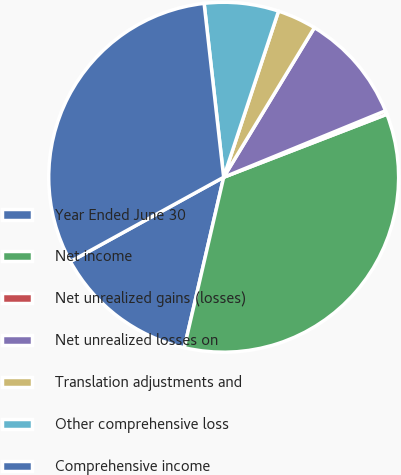<chart> <loc_0><loc_0><loc_500><loc_500><pie_chart><fcel>Year Ended June 30<fcel>Net income<fcel>Net unrealized gains (losses)<fcel>Net unrealized losses on<fcel>Translation adjustments and<fcel>Other comprehensive loss<fcel>Comprehensive income<nl><fcel>13.38%<fcel>34.48%<fcel>0.34%<fcel>10.12%<fcel>3.6%<fcel>6.86%<fcel>31.22%<nl></chart> 